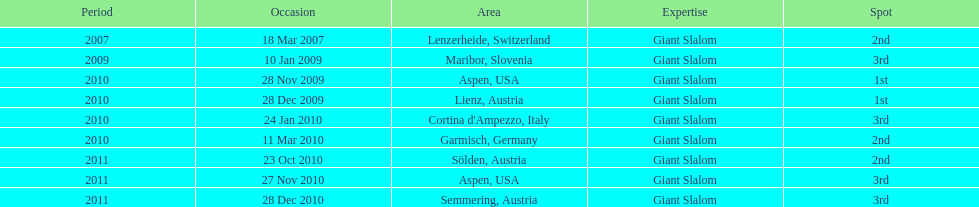What is the total number of her 2nd place finishes on the list? 3. 